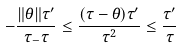<formula> <loc_0><loc_0><loc_500><loc_500>- \frac { \| \theta \| \tau ^ { \prime } } { \tau _ { - } \tau } \leq \frac { ( \tau - \theta ) \tau ^ { \prime } } { \tau ^ { 2 } } \leq \frac { \tau ^ { \prime } } { \tau }</formula> 